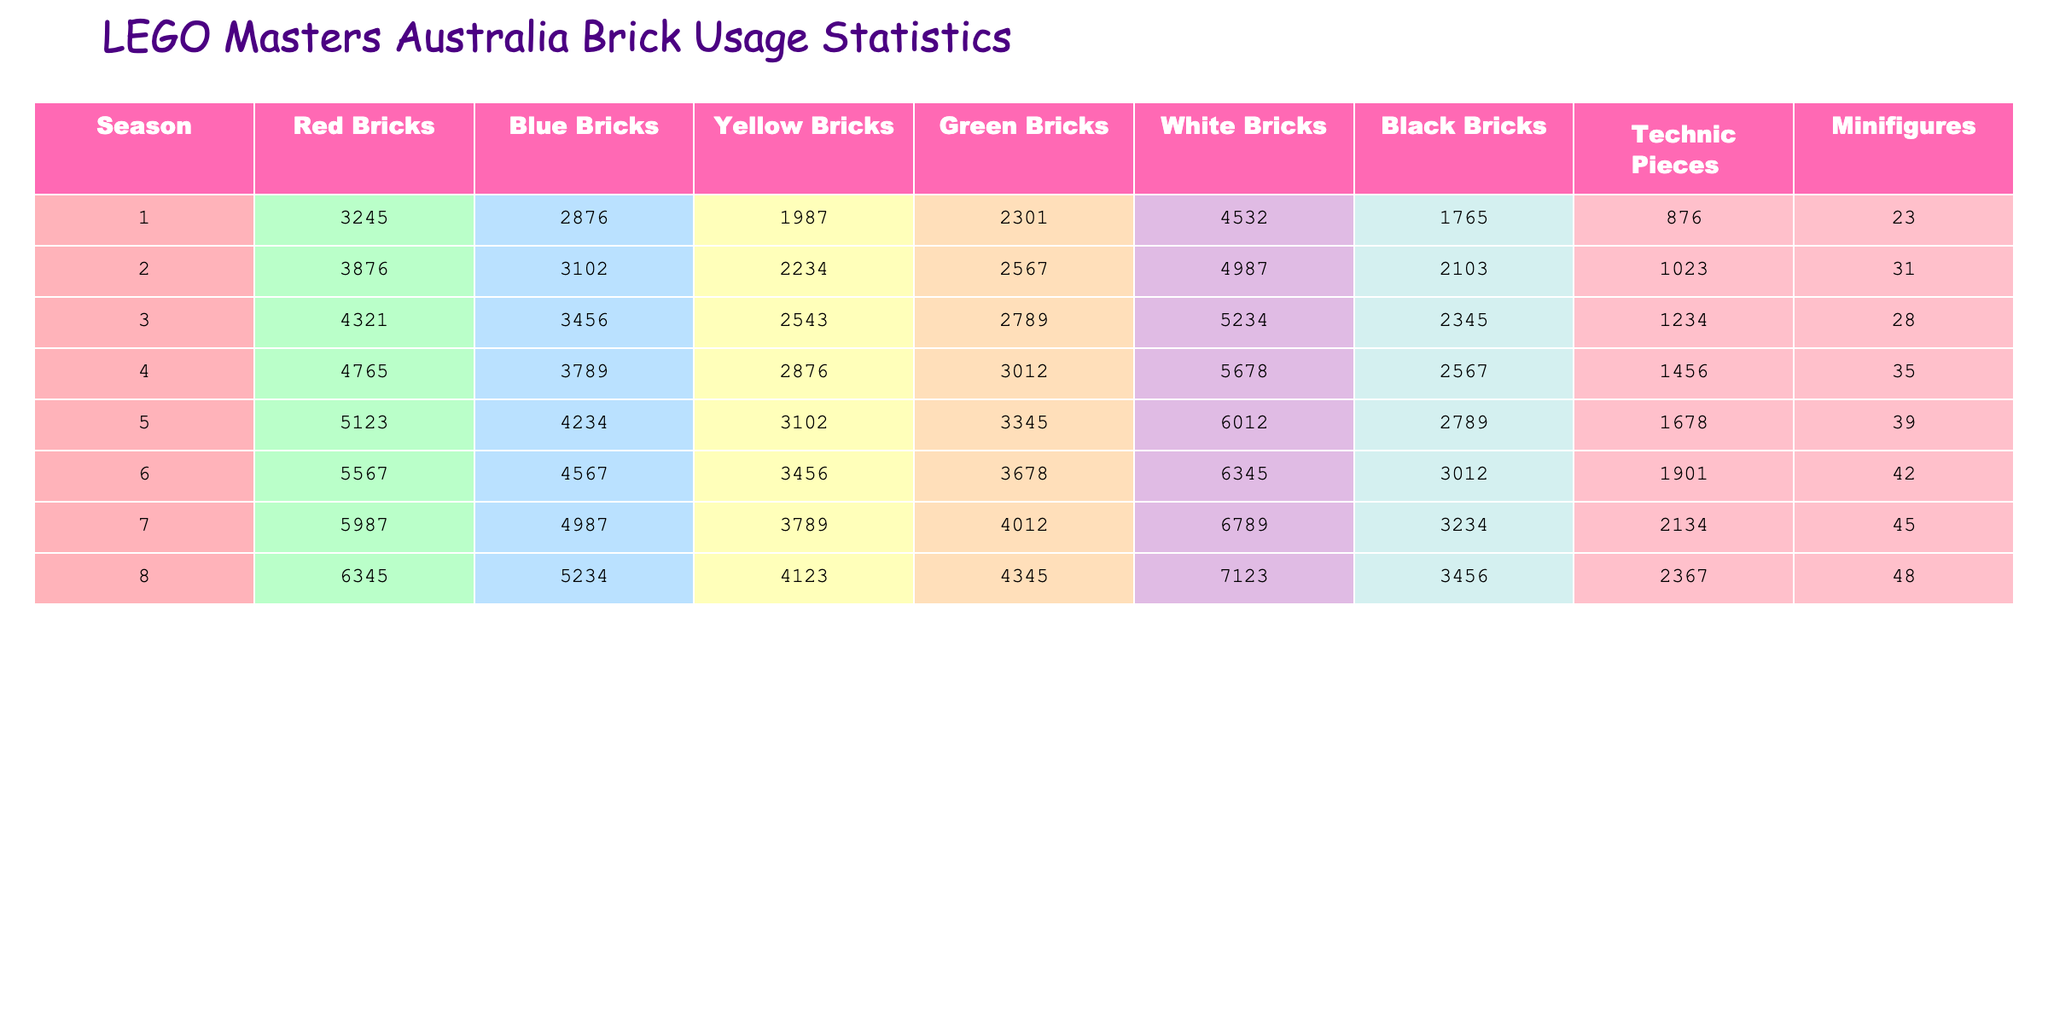What is the total number of red bricks used in the final builds across all seasons? To find the total number of red bricks, sum the values from each season: 3245 + 3876 + 4321 + 4765 + 5123 + 5567 + 5987 + 6345 =  36809
Answer: 36809 Which season used the most yellow bricks? Looking down the yellow bricks column, season 8 has the highest value of 4123 yellow bricks.
Answer: Season 8 What is the average number of technic pieces used per season? To calculate the average, sum the technic pieces: 876 + 1023 + 1234 + 1456 + 1678 + 1901 + 2134 + 2367 = 10269. Then divide by the number of seasons (8): 10269 / 8 = 1283.625.
Answer: 1283.625 Did any season use more than 6000 white bricks? Only the last season, season 8, has 7123 white bricks which is more than 6000.
Answer: Yes How many more black bricks were used in season 7 compared to season 1? The number of black bricks in season 7 is 3234 and in season 1 is 1765. The difference is 3234 - 1765 = 1469.
Answer: 1469 What is the cumulative total of blue bricks used from season 1 to season 5? Sum the blue bricks from each of the first five seasons: 2876 + 3102 + 3456 + 3789 + 4234 = 17457.
Answer: 17457 Is the number of minifigures in season 6 greater than the average number of minifigures across all seasons? First, compute the average of minifigures: (23 + 31 + 28 + 35 + 39 + 42 + 45 + 48) / 8 = 36. So, since season 6 has 42 minifigures, which is greater than 36, the answer is yes.
Answer: Yes Which season saw the least usage of green bricks? By examining the values in the green bricks column, season 1 has the least at 2301 green bricks.
Answer: Season 1 What is the total number of bricks (all colors) used in season 4? Add up the bricks in season 4: 4765 (red) + 3789 (blue) + 2876 (yellow) + 3012 (green) + 5678 (white) + 2567 (black) + 1456 (technic) + 35 (minifigures) = 20578.
Answer: 20578 Which season has the highest total count of bricks when combining all types? Calculate the total for each season and compare: 
- Season 1: 3245 + 2876 + 1987 + 2301 + 4532 + 1765 + 876 + 23 = 18705 
- Season 2: 3876 + 3102 + 2234 + 2567 + 4987 + 2103 + 1023 + 31 = 19993 
- Season 3: 4321 + 3456 + 2543 + 2789 + 5234 + 2345 + 1234 + 28 = 21847 
- Season 4: 4765 + 3789 + 2876 + 3012 + 5678 + 2567 + 1456 + 35 = 20578 
- Season 5: 5123 + 4234 + 3102 + 3345 + 6012 + 2789 + 1678 + 39 = 22322 
- Season 6: 5567 + 4567 + 3456 + 3678 + 6345 + 3012 + 1901 + 42 = 25068 
- Season 7: 5987 + 4987 + 3789 + 4012 + 6789 + 3234 + 2134 + 45 = 24184 
- Season 8: 6345 + 5234 + 4123 + 4345 + 7123 + 3456 + 2367 + 48 = 29967 
Season 8 has the highest total with 29967.
Answer: Season 8 